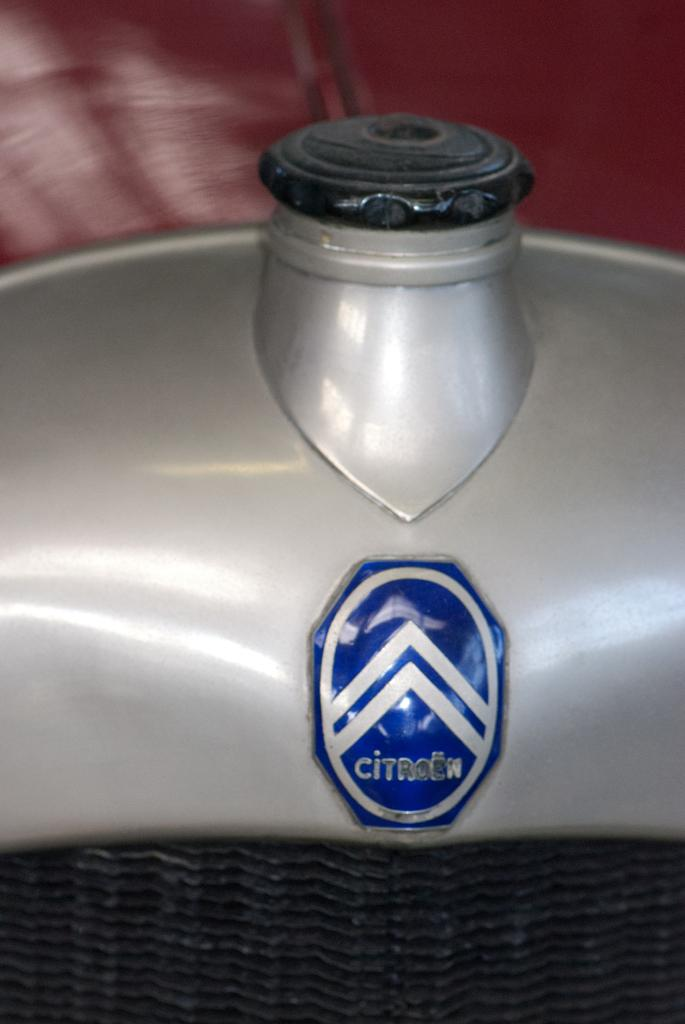What is the main object in the image? There is a black and grey color object in the image. What color is the attached part of the object? There is a blue color batch attached to the object. What color is the background of the image? The background of the image is maroon in color. What type of hair can be seen on the person in the image? There is no person present in the image, so it is not possible to determine the type of hair. 